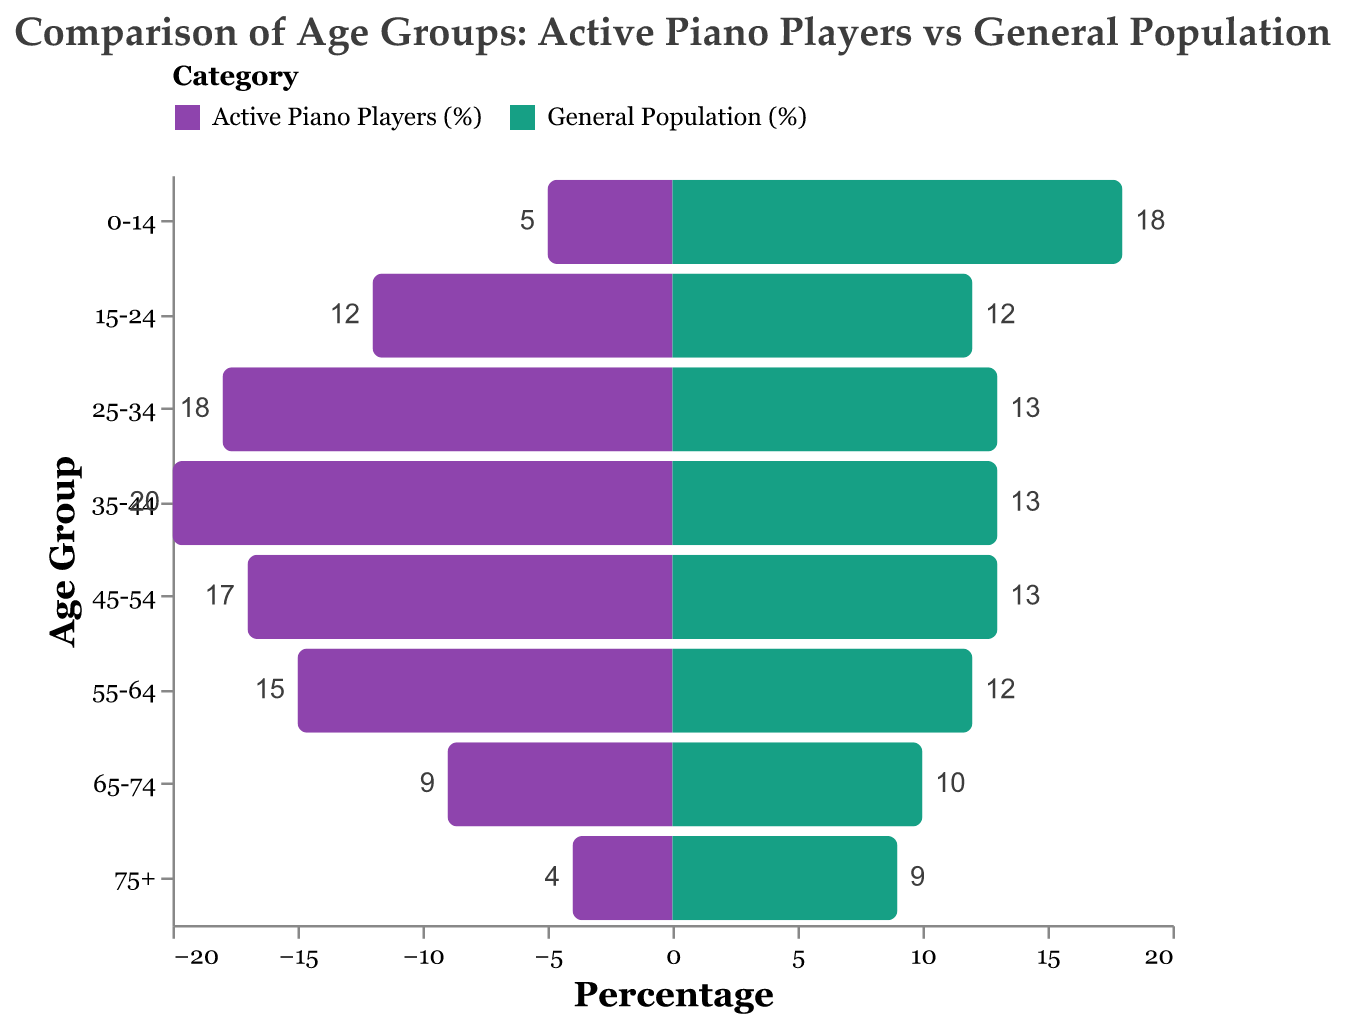What is the color representing Active Piano Players (%)? The color representing "Active Piano Players (%)" in the figure is purple.
Answer: Purple What percentage of the general population is in the age group 0-14? The bar for the age group 0-14 in the general population category reaches up to 18%.
Answer: 18% How does the percentage of Active Piano Players in the age group 35-44 compare to the general population in the same age group? For the age group 35-44, Active Piano Players (%) is 20%, while the General Population (%) is 13%. So, Active Piano Players have a higher percentage.
Answer: Higher Which age group has the highest percentage of Active Piano Players? The bar for Active Piano Players is highest for the age group 35-44, reaching 20%.
Answer: 35-44 What is the difference between the percentage of Active Piano Players and the general population in the age group 0-14? The percentage of Active Piano Players in the age group 0-14 is 5%, while the general population is 18%. The difference is 18% - 5% = 13%.
Answer: 13% Which age group has the smallest percentage of Active Piano Players? The bar for Active Piano Players is smallest for the age group 75+, reaching only 4%.
Answer: 75+ Are there any age groups where the percentage of Active Piano Players is the same as the general population? In the age group 15-24, both Active Piano Players and the general population have a percentage of 12%.
Answer: 15-24 What is the total percentage of Active Piano Players for the age groups 25-34 and 35-44? The percentages for the age groups 25-34 and 35-44 for Active Piano Players are 18% and 20%, respectively. Adding them gives 18% + 20% = 38%.
Answer: 38% In which age group does the general population have the highest percentage? The highest percentage for the general population is in the age group 0-14, which is 18%.
Answer: 0-14 How much higher is the percentage of Active Piano Players in the age group 45-54 compared to the general population in the same age group? Both groups in the age category 45-54 show Active Piano Players at 17% and the general population at 13%. The difference is 17% - 13% = 4%.
Answer: 4% 